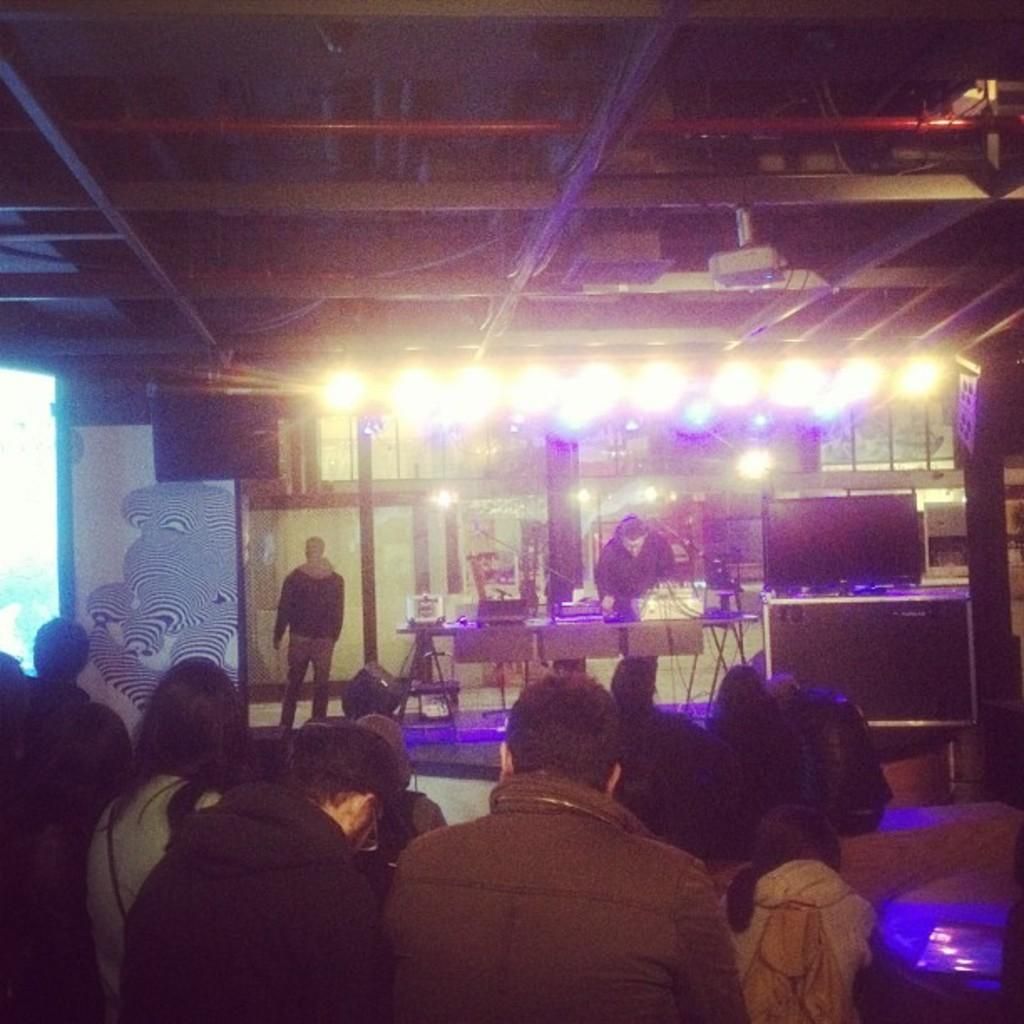Who or what can be seen in the image? There are people in the image. What is located on the table in the image? There is a table with objects in the image. What can be used to provide illumination in the image? There are lights visible in the image. What type of electronic device is on the right side of the image? There is a television on the right side of the image. What fact can be learned about the fear of spiders from the image? There is no information about the fear of spiders or any spiders present in the image. 